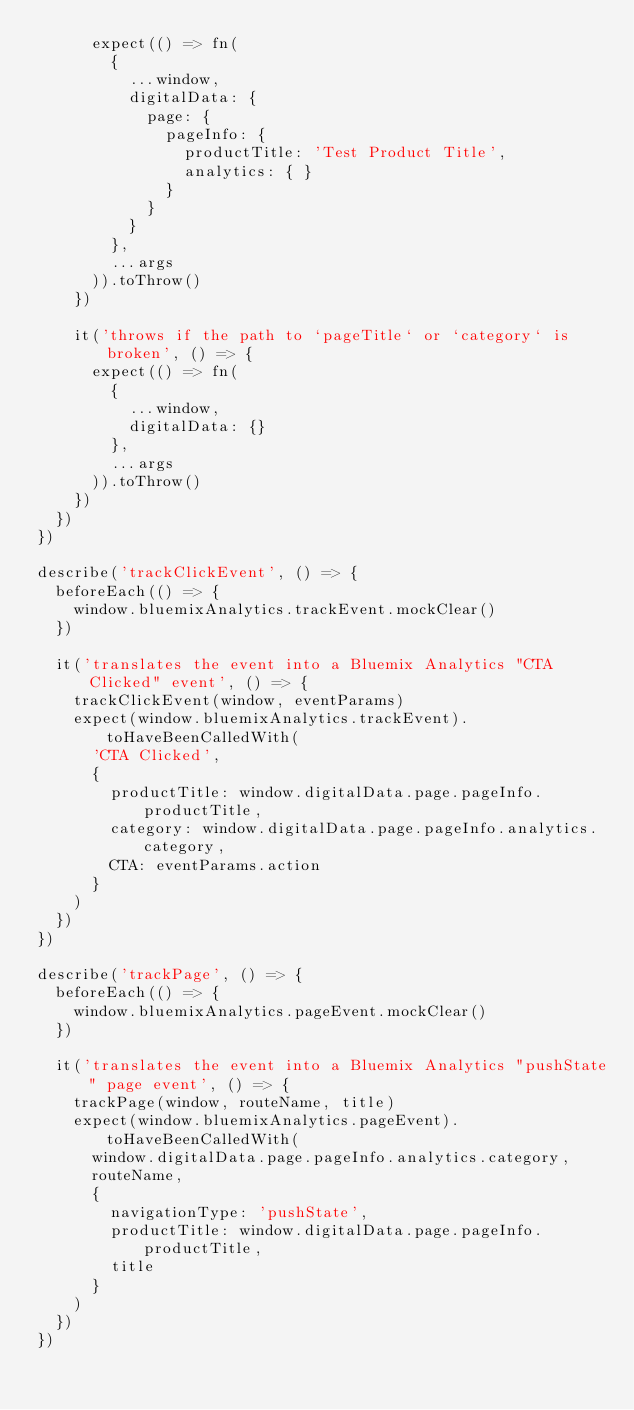Convert code to text. <code><loc_0><loc_0><loc_500><loc_500><_TypeScript_>      expect(() => fn(
        {
          ...window,
          digitalData: {
            page: {
              pageInfo: {
                productTitle: 'Test Product Title',
                analytics: { }
              }
            }
          }
        },
        ...args
      )).toThrow()
    })

    it('throws if the path to `pageTitle` or `category` is broken', () => {
      expect(() => fn(
        {
          ...window,
          digitalData: {}
        },
        ...args
      )).toThrow()
    })
  })
})

describe('trackClickEvent', () => {
  beforeEach(() => {
    window.bluemixAnalytics.trackEvent.mockClear()
  })

  it('translates the event into a Bluemix Analytics "CTA Clicked" event', () => {
    trackClickEvent(window, eventParams)
    expect(window.bluemixAnalytics.trackEvent).toHaveBeenCalledWith(
      'CTA Clicked',
      {
        productTitle: window.digitalData.page.pageInfo.productTitle,
        category: window.digitalData.page.pageInfo.analytics.category,
        CTA: eventParams.action
      }
    )
  })
})

describe('trackPage', () => {
  beforeEach(() => {
    window.bluemixAnalytics.pageEvent.mockClear()
  })

  it('translates the event into a Bluemix Analytics "pushState" page event', () => {
    trackPage(window, routeName, title)
    expect(window.bluemixAnalytics.pageEvent).toHaveBeenCalledWith(
      window.digitalData.page.pageInfo.analytics.category,
      routeName,
      {
        navigationType: 'pushState',
        productTitle: window.digitalData.page.pageInfo.productTitle,
        title
      }
    )
  })
})
</code> 